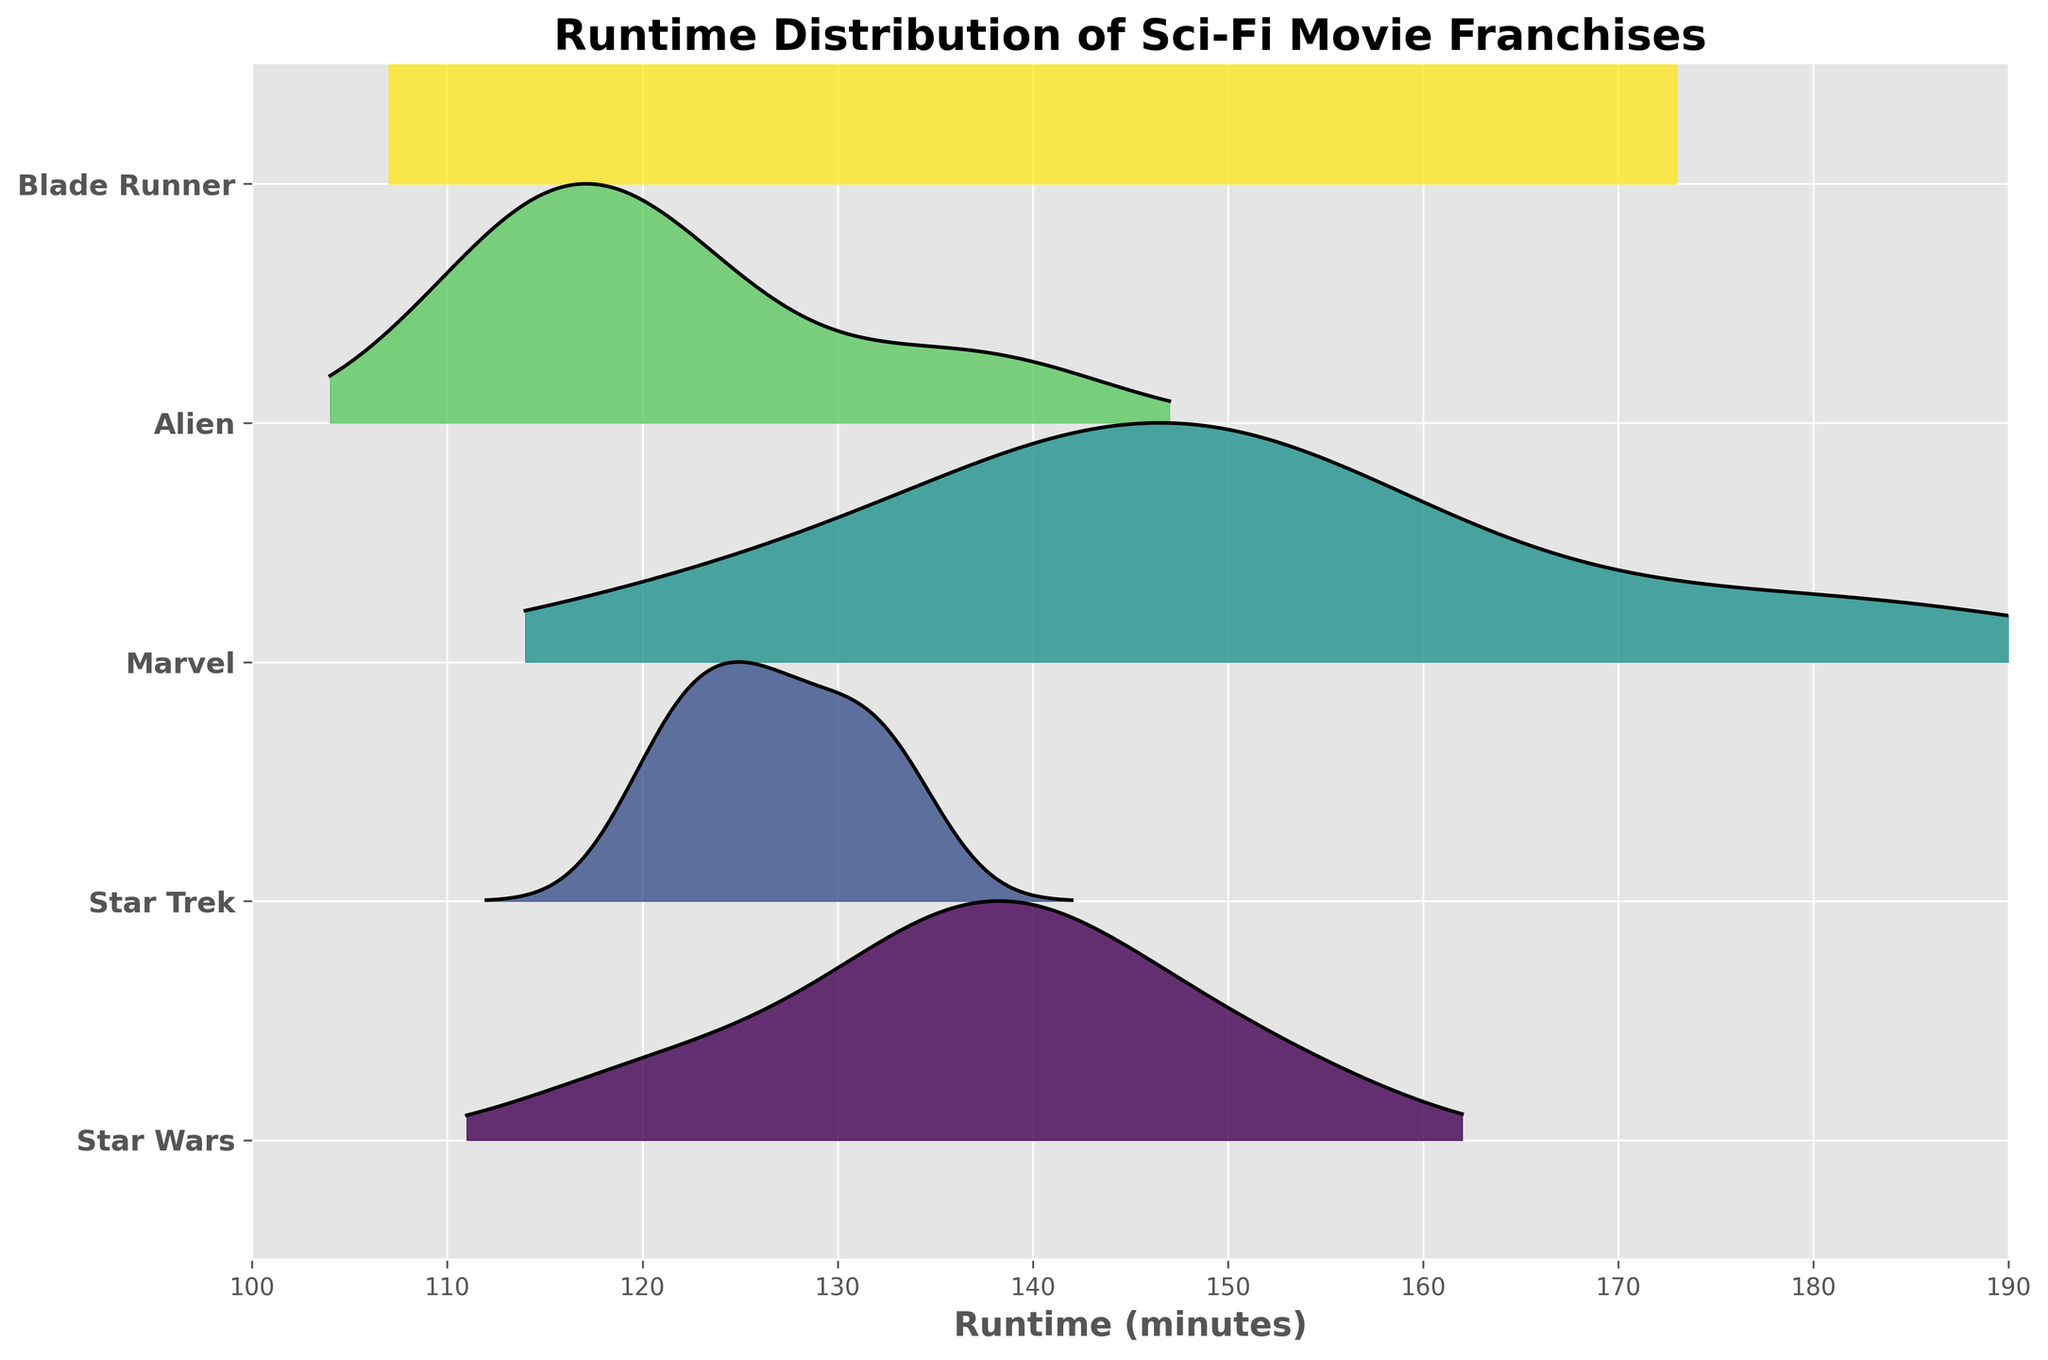What is the title of the figure? The title of the figure is usually placed at the top center and clearly visible.
Answer: Runtime Distribution of Sci-Fi Movie Franchises Which franchise has the highest peak in the runtime distribution? By observing the ridgeline plot, the franchise curve that reaches the highest point indicates the highest peak.
Answer: Marvel How many different franchises are compared in the plot? Count the number of unique franchise names listed on the y-axis.
Answer: 5 Which franchise has the lowest average runtime? The lowest average runtime would be indicated by the franchise with the distribution skewed towards the lower end on the x-axis.
Answer: Blade Runner Which franchises have runtime distributions that overlap? Identify distributions with significant overlapping areas on the x-axis ranges.
Answer: Star Wars, Star Trek, and Marvel For the franchise with the highest average runtime, what is this approximate average? The approximate average runtime can be inferred from the center of the distribution curve for the franchise with the highest average runtime.
Answer: Around 150-160 minutes Do any of the franchises have a runtime that exceeds 180 minutes? Check the rightmost end of the x-axis for any peaks or extensions from the curves.
Answer: Marvel What is the range of runtimes for the Star Wars franchise? Identify the start and end points of the Star Wars distribution and calculate the range.
Answer: 121 - 152 minutes Which franchise appears to have the most consistent runtime (least variability)? The franchise with the narrowest curve width (smallest spread) has the most consistent runtime.
Answer: Blade Runner 